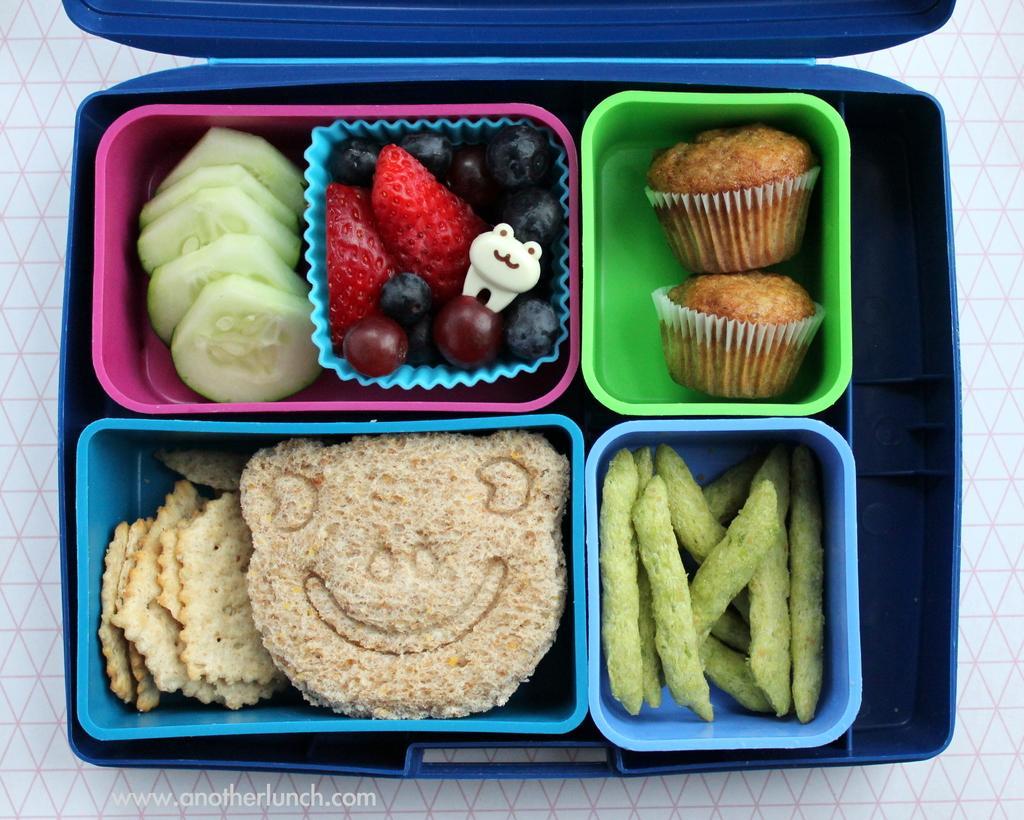Describe this image in one or two sentences. In this picture I can see there is a lunch box, there are fruits, sliced cucumber, sandwich, cupcakes and some other food. It is placed on a white surface and there is a watermark at the left side bottom of the image. 